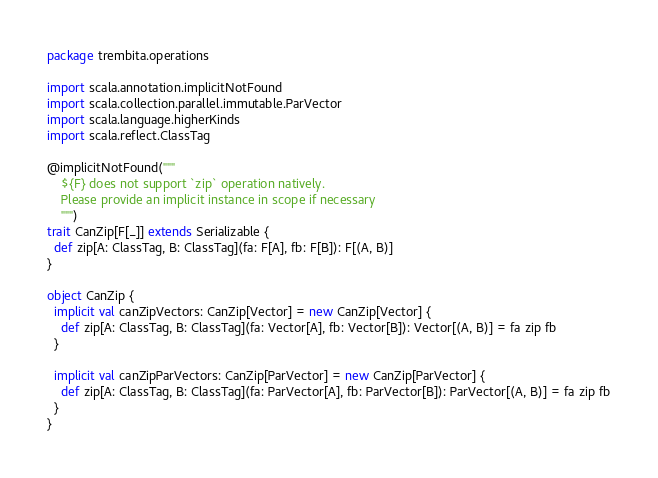Convert code to text. <code><loc_0><loc_0><loc_500><loc_500><_Scala_>package trembita.operations

import scala.annotation.implicitNotFound
import scala.collection.parallel.immutable.ParVector
import scala.language.higherKinds
import scala.reflect.ClassTag

@implicitNotFound("""
    ${F} does not support `zip` operation natively.
    Please provide an implicit instance in scope if necessary
    """)
trait CanZip[F[_]] extends Serializable {
  def zip[A: ClassTag, B: ClassTag](fa: F[A], fb: F[B]): F[(A, B)]
}

object CanZip {
  implicit val canZipVectors: CanZip[Vector] = new CanZip[Vector] {
    def zip[A: ClassTag, B: ClassTag](fa: Vector[A], fb: Vector[B]): Vector[(A, B)] = fa zip fb
  }

  implicit val canZipParVectors: CanZip[ParVector] = new CanZip[ParVector] {
    def zip[A: ClassTag, B: ClassTag](fa: ParVector[A], fb: ParVector[B]): ParVector[(A, B)] = fa zip fb
  }
}
</code> 